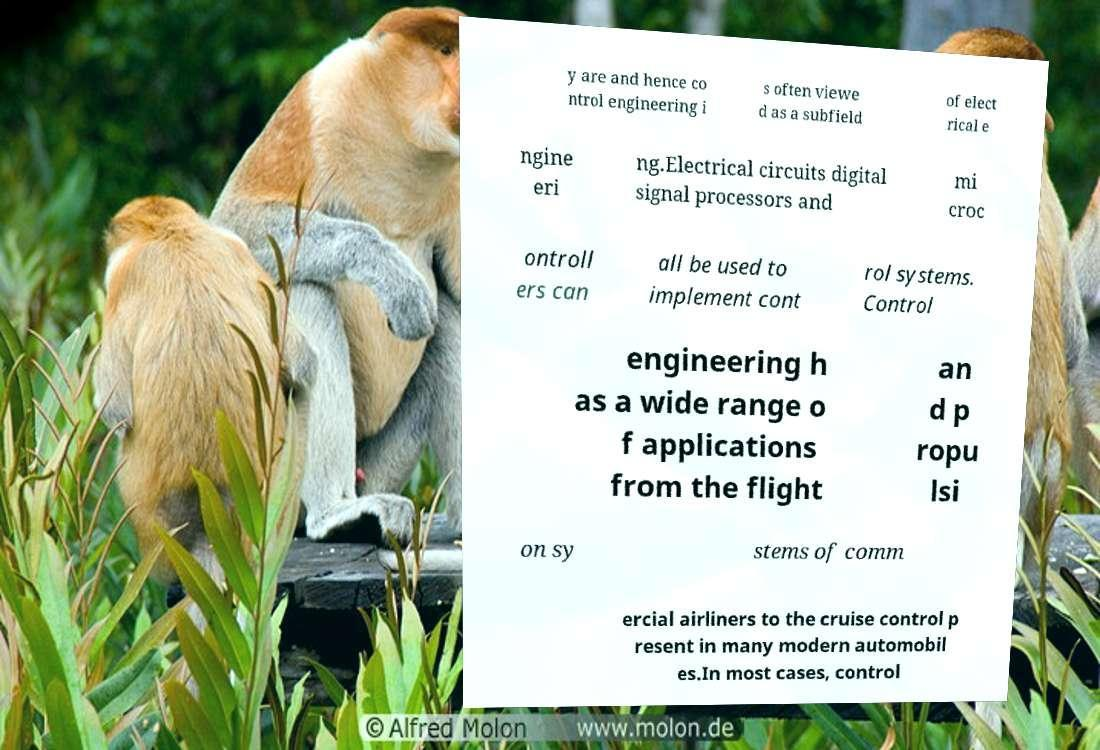For documentation purposes, I need the text within this image transcribed. Could you provide that? y are and hence co ntrol engineering i s often viewe d as a subfield of elect rical e ngine eri ng.Electrical circuits digital signal processors and mi croc ontroll ers can all be used to implement cont rol systems. Control engineering h as a wide range o f applications from the flight an d p ropu lsi on sy stems of comm ercial airliners to the cruise control p resent in many modern automobil es.In most cases, control 